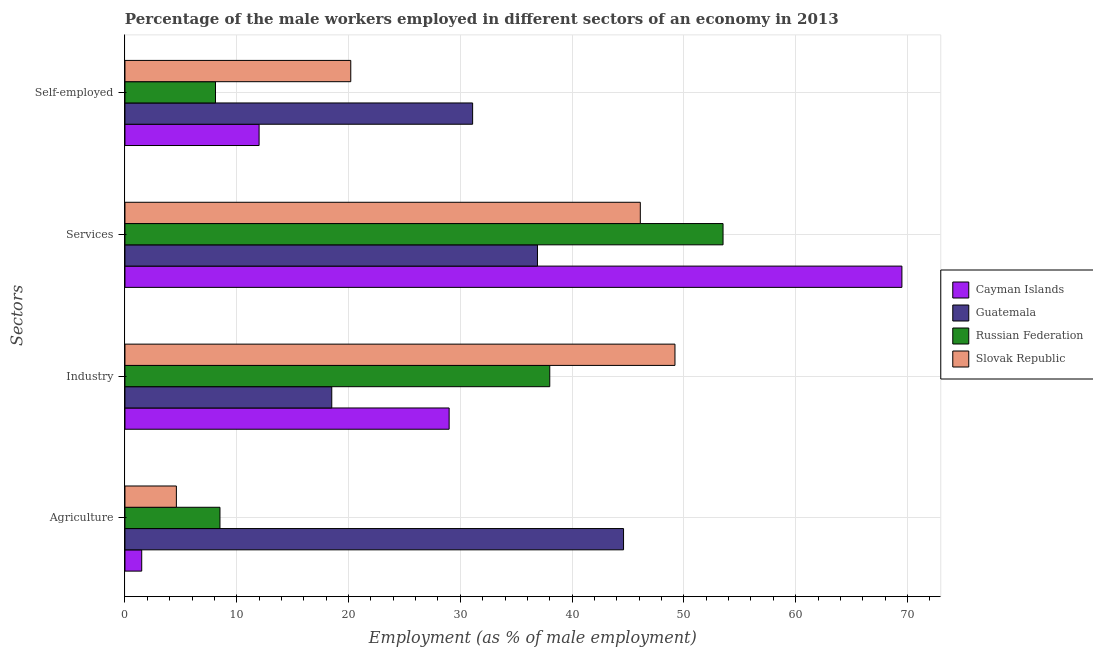Are the number of bars on each tick of the Y-axis equal?
Provide a succinct answer. Yes. What is the label of the 4th group of bars from the top?
Give a very brief answer. Agriculture. What is the percentage of self employed male workers in Russian Federation?
Offer a terse response. 8.1. Across all countries, what is the maximum percentage of male workers in industry?
Your response must be concise. 49.2. Across all countries, what is the minimum percentage of male workers in services?
Keep it short and to the point. 36.9. In which country was the percentage of self employed male workers maximum?
Provide a succinct answer. Guatemala. In which country was the percentage of male workers in industry minimum?
Make the answer very short. Guatemala. What is the total percentage of male workers in industry in the graph?
Your answer should be compact. 134.7. What is the difference between the percentage of male workers in agriculture in Guatemala and that in Slovak Republic?
Give a very brief answer. 40. What is the difference between the percentage of self employed male workers in Russian Federation and the percentage of male workers in services in Cayman Islands?
Ensure brevity in your answer.  -61.4. What is the average percentage of self employed male workers per country?
Make the answer very short. 17.85. What is the difference between the percentage of male workers in services and percentage of male workers in industry in Cayman Islands?
Provide a succinct answer. 40.5. What is the ratio of the percentage of male workers in services in Slovak Republic to that in Guatemala?
Keep it short and to the point. 1.25. Is the difference between the percentage of self employed male workers in Guatemala and Russian Federation greater than the difference between the percentage of male workers in industry in Guatemala and Russian Federation?
Provide a succinct answer. Yes. What is the difference between the highest and the second highest percentage of male workers in industry?
Your response must be concise. 11.2. What is the difference between the highest and the lowest percentage of male workers in agriculture?
Your response must be concise. 43.1. In how many countries, is the percentage of self employed male workers greater than the average percentage of self employed male workers taken over all countries?
Keep it short and to the point. 2. Is it the case that in every country, the sum of the percentage of self employed male workers and percentage of male workers in services is greater than the sum of percentage of male workers in industry and percentage of male workers in agriculture?
Keep it short and to the point. Yes. What does the 4th bar from the top in Services represents?
Provide a short and direct response. Cayman Islands. What does the 4th bar from the bottom in Services represents?
Provide a succinct answer. Slovak Republic. Are all the bars in the graph horizontal?
Ensure brevity in your answer.  Yes. How many countries are there in the graph?
Your response must be concise. 4. Are the values on the major ticks of X-axis written in scientific E-notation?
Your answer should be compact. No. Does the graph contain any zero values?
Offer a very short reply. No. Does the graph contain grids?
Give a very brief answer. Yes. How many legend labels are there?
Your answer should be compact. 4. How are the legend labels stacked?
Provide a short and direct response. Vertical. What is the title of the graph?
Give a very brief answer. Percentage of the male workers employed in different sectors of an economy in 2013. What is the label or title of the X-axis?
Your response must be concise. Employment (as % of male employment). What is the label or title of the Y-axis?
Provide a succinct answer. Sectors. What is the Employment (as % of male employment) in Cayman Islands in Agriculture?
Offer a terse response. 1.5. What is the Employment (as % of male employment) of Guatemala in Agriculture?
Ensure brevity in your answer.  44.6. What is the Employment (as % of male employment) of Russian Federation in Agriculture?
Provide a short and direct response. 8.5. What is the Employment (as % of male employment) in Slovak Republic in Agriculture?
Your response must be concise. 4.6. What is the Employment (as % of male employment) of Cayman Islands in Industry?
Offer a very short reply. 29. What is the Employment (as % of male employment) of Russian Federation in Industry?
Provide a short and direct response. 38. What is the Employment (as % of male employment) in Slovak Republic in Industry?
Make the answer very short. 49.2. What is the Employment (as % of male employment) in Cayman Islands in Services?
Make the answer very short. 69.5. What is the Employment (as % of male employment) in Guatemala in Services?
Provide a succinct answer. 36.9. What is the Employment (as % of male employment) of Russian Federation in Services?
Offer a very short reply. 53.5. What is the Employment (as % of male employment) of Slovak Republic in Services?
Offer a terse response. 46.1. What is the Employment (as % of male employment) in Guatemala in Self-employed?
Offer a very short reply. 31.1. What is the Employment (as % of male employment) in Russian Federation in Self-employed?
Offer a very short reply. 8.1. What is the Employment (as % of male employment) of Slovak Republic in Self-employed?
Provide a succinct answer. 20.2. Across all Sectors, what is the maximum Employment (as % of male employment) in Cayman Islands?
Offer a very short reply. 69.5. Across all Sectors, what is the maximum Employment (as % of male employment) in Guatemala?
Make the answer very short. 44.6. Across all Sectors, what is the maximum Employment (as % of male employment) in Russian Federation?
Your answer should be compact. 53.5. Across all Sectors, what is the maximum Employment (as % of male employment) in Slovak Republic?
Make the answer very short. 49.2. Across all Sectors, what is the minimum Employment (as % of male employment) of Russian Federation?
Provide a short and direct response. 8.1. Across all Sectors, what is the minimum Employment (as % of male employment) in Slovak Republic?
Keep it short and to the point. 4.6. What is the total Employment (as % of male employment) in Cayman Islands in the graph?
Your response must be concise. 112. What is the total Employment (as % of male employment) in Guatemala in the graph?
Your answer should be very brief. 131.1. What is the total Employment (as % of male employment) in Russian Federation in the graph?
Offer a very short reply. 108.1. What is the total Employment (as % of male employment) of Slovak Republic in the graph?
Give a very brief answer. 120.1. What is the difference between the Employment (as % of male employment) of Cayman Islands in Agriculture and that in Industry?
Offer a terse response. -27.5. What is the difference between the Employment (as % of male employment) of Guatemala in Agriculture and that in Industry?
Give a very brief answer. 26.1. What is the difference between the Employment (as % of male employment) in Russian Federation in Agriculture and that in Industry?
Your answer should be very brief. -29.5. What is the difference between the Employment (as % of male employment) of Slovak Republic in Agriculture and that in Industry?
Keep it short and to the point. -44.6. What is the difference between the Employment (as % of male employment) of Cayman Islands in Agriculture and that in Services?
Ensure brevity in your answer.  -68. What is the difference between the Employment (as % of male employment) in Russian Federation in Agriculture and that in Services?
Ensure brevity in your answer.  -45. What is the difference between the Employment (as % of male employment) in Slovak Republic in Agriculture and that in Services?
Your answer should be very brief. -41.5. What is the difference between the Employment (as % of male employment) of Cayman Islands in Agriculture and that in Self-employed?
Keep it short and to the point. -10.5. What is the difference between the Employment (as % of male employment) in Guatemala in Agriculture and that in Self-employed?
Provide a succinct answer. 13.5. What is the difference between the Employment (as % of male employment) of Slovak Republic in Agriculture and that in Self-employed?
Make the answer very short. -15.6. What is the difference between the Employment (as % of male employment) in Cayman Islands in Industry and that in Services?
Give a very brief answer. -40.5. What is the difference between the Employment (as % of male employment) in Guatemala in Industry and that in Services?
Offer a terse response. -18.4. What is the difference between the Employment (as % of male employment) in Russian Federation in Industry and that in Services?
Ensure brevity in your answer.  -15.5. What is the difference between the Employment (as % of male employment) of Guatemala in Industry and that in Self-employed?
Provide a short and direct response. -12.6. What is the difference between the Employment (as % of male employment) in Russian Federation in Industry and that in Self-employed?
Your answer should be very brief. 29.9. What is the difference between the Employment (as % of male employment) of Slovak Republic in Industry and that in Self-employed?
Keep it short and to the point. 29. What is the difference between the Employment (as % of male employment) in Cayman Islands in Services and that in Self-employed?
Give a very brief answer. 57.5. What is the difference between the Employment (as % of male employment) of Guatemala in Services and that in Self-employed?
Your answer should be compact. 5.8. What is the difference between the Employment (as % of male employment) in Russian Federation in Services and that in Self-employed?
Offer a very short reply. 45.4. What is the difference between the Employment (as % of male employment) of Slovak Republic in Services and that in Self-employed?
Your response must be concise. 25.9. What is the difference between the Employment (as % of male employment) in Cayman Islands in Agriculture and the Employment (as % of male employment) in Russian Federation in Industry?
Provide a short and direct response. -36.5. What is the difference between the Employment (as % of male employment) in Cayman Islands in Agriculture and the Employment (as % of male employment) in Slovak Republic in Industry?
Offer a very short reply. -47.7. What is the difference between the Employment (as % of male employment) of Guatemala in Agriculture and the Employment (as % of male employment) of Russian Federation in Industry?
Offer a terse response. 6.6. What is the difference between the Employment (as % of male employment) of Russian Federation in Agriculture and the Employment (as % of male employment) of Slovak Republic in Industry?
Give a very brief answer. -40.7. What is the difference between the Employment (as % of male employment) in Cayman Islands in Agriculture and the Employment (as % of male employment) in Guatemala in Services?
Offer a terse response. -35.4. What is the difference between the Employment (as % of male employment) in Cayman Islands in Agriculture and the Employment (as % of male employment) in Russian Federation in Services?
Offer a very short reply. -52. What is the difference between the Employment (as % of male employment) in Cayman Islands in Agriculture and the Employment (as % of male employment) in Slovak Republic in Services?
Ensure brevity in your answer.  -44.6. What is the difference between the Employment (as % of male employment) in Guatemala in Agriculture and the Employment (as % of male employment) in Russian Federation in Services?
Your answer should be compact. -8.9. What is the difference between the Employment (as % of male employment) of Russian Federation in Agriculture and the Employment (as % of male employment) of Slovak Republic in Services?
Keep it short and to the point. -37.6. What is the difference between the Employment (as % of male employment) in Cayman Islands in Agriculture and the Employment (as % of male employment) in Guatemala in Self-employed?
Offer a terse response. -29.6. What is the difference between the Employment (as % of male employment) of Cayman Islands in Agriculture and the Employment (as % of male employment) of Russian Federation in Self-employed?
Your response must be concise. -6.6. What is the difference between the Employment (as % of male employment) of Cayman Islands in Agriculture and the Employment (as % of male employment) of Slovak Republic in Self-employed?
Provide a short and direct response. -18.7. What is the difference between the Employment (as % of male employment) in Guatemala in Agriculture and the Employment (as % of male employment) in Russian Federation in Self-employed?
Your response must be concise. 36.5. What is the difference between the Employment (as % of male employment) of Guatemala in Agriculture and the Employment (as % of male employment) of Slovak Republic in Self-employed?
Make the answer very short. 24.4. What is the difference between the Employment (as % of male employment) of Russian Federation in Agriculture and the Employment (as % of male employment) of Slovak Republic in Self-employed?
Your response must be concise. -11.7. What is the difference between the Employment (as % of male employment) of Cayman Islands in Industry and the Employment (as % of male employment) of Guatemala in Services?
Your answer should be compact. -7.9. What is the difference between the Employment (as % of male employment) of Cayman Islands in Industry and the Employment (as % of male employment) of Russian Federation in Services?
Your response must be concise. -24.5. What is the difference between the Employment (as % of male employment) of Cayman Islands in Industry and the Employment (as % of male employment) of Slovak Republic in Services?
Your answer should be very brief. -17.1. What is the difference between the Employment (as % of male employment) in Guatemala in Industry and the Employment (as % of male employment) in Russian Federation in Services?
Keep it short and to the point. -35. What is the difference between the Employment (as % of male employment) in Guatemala in Industry and the Employment (as % of male employment) in Slovak Republic in Services?
Ensure brevity in your answer.  -27.6. What is the difference between the Employment (as % of male employment) of Russian Federation in Industry and the Employment (as % of male employment) of Slovak Republic in Services?
Offer a terse response. -8.1. What is the difference between the Employment (as % of male employment) in Cayman Islands in Industry and the Employment (as % of male employment) in Russian Federation in Self-employed?
Offer a terse response. 20.9. What is the difference between the Employment (as % of male employment) in Guatemala in Industry and the Employment (as % of male employment) in Russian Federation in Self-employed?
Ensure brevity in your answer.  10.4. What is the difference between the Employment (as % of male employment) in Guatemala in Industry and the Employment (as % of male employment) in Slovak Republic in Self-employed?
Offer a terse response. -1.7. What is the difference between the Employment (as % of male employment) in Russian Federation in Industry and the Employment (as % of male employment) in Slovak Republic in Self-employed?
Your answer should be very brief. 17.8. What is the difference between the Employment (as % of male employment) of Cayman Islands in Services and the Employment (as % of male employment) of Guatemala in Self-employed?
Offer a very short reply. 38.4. What is the difference between the Employment (as % of male employment) of Cayman Islands in Services and the Employment (as % of male employment) of Russian Federation in Self-employed?
Your answer should be very brief. 61.4. What is the difference between the Employment (as % of male employment) of Cayman Islands in Services and the Employment (as % of male employment) of Slovak Republic in Self-employed?
Provide a short and direct response. 49.3. What is the difference between the Employment (as % of male employment) in Guatemala in Services and the Employment (as % of male employment) in Russian Federation in Self-employed?
Ensure brevity in your answer.  28.8. What is the difference between the Employment (as % of male employment) of Guatemala in Services and the Employment (as % of male employment) of Slovak Republic in Self-employed?
Keep it short and to the point. 16.7. What is the difference between the Employment (as % of male employment) of Russian Federation in Services and the Employment (as % of male employment) of Slovak Republic in Self-employed?
Give a very brief answer. 33.3. What is the average Employment (as % of male employment) of Guatemala per Sectors?
Make the answer very short. 32.77. What is the average Employment (as % of male employment) in Russian Federation per Sectors?
Your answer should be very brief. 27.02. What is the average Employment (as % of male employment) in Slovak Republic per Sectors?
Provide a succinct answer. 30.02. What is the difference between the Employment (as % of male employment) in Cayman Islands and Employment (as % of male employment) in Guatemala in Agriculture?
Your response must be concise. -43.1. What is the difference between the Employment (as % of male employment) of Cayman Islands and Employment (as % of male employment) of Slovak Republic in Agriculture?
Offer a very short reply. -3.1. What is the difference between the Employment (as % of male employment) of Guatemala and Employment (as % of male employment) of Russian Federation in Agriculture?
Make the answer very short. 36.1. What is the difference between the Employment (as % of male employment) of Russian Federation and Employment (as % of male employment) of Slovak Republic in Agriculture?
Keep it short and to the point. 3.9. What is the difference between the Employment (as % of male employment) in Cayman Islands and Employment (as % of male employment) in Slovak Republic in Industry?
Offer a terse response. -20.2. What is the difference between the Employment (as % of male employment) in Guatemala and Employment (as % of male employment) in Russian Federation in Industry?
Make the answer very short. -19.5. What is the difference between the Employment (as % of male employment) in Guatemala and Employment (as % of male employment) in Slovak Republic in Industry?
Provide a short and direct response. -30.7. What is the difference between the Employment (as % of male employment) of Cayman Islands and Employment (as % of male employment) of Guatemala in Services?
Your response must be concise. 32.6. What is the difference between the Employment (as % of male employment) of Cayman Islands and Employment (as % of male employment) of Slovak Republic in Services?
Offer a very short reply. 23.4. What is the difference between the Employment (as % of male employment) in Guatemala and Employment (as % of male employment) in Russian Federation in Services?
Provide a short and direct response. -16.6. What is the difference between the Employment (as % of male employment) in Cayman Islands and Employment (as % of male employment) in Guatemala in Self-employed?
Offer a terse response. -19.1. What is the difference between the Employment (as % of male employment) in Guatemala and Employment (as % of male employment) in Russian Federation in Self-employed?
Your response must be concise. 23. What is the difference between the Employment (as % of male employment) in Guatemala and Employment (as % of male employment) in Slovak Republic in Self-employed?
Provide a short and direct response. 10.9. What is the difference between the Employment (as % of male employment) of Russian Federation and Employment (as % of male employment) of Slovak Republic in Self-employed?
Offer a very short reply. -12.1. What is the ratio of the Employment (as % of male employment) in Cayman Islands in Agriculture to that in Industry?
Offer a very short reply. 0.05. What is the ratio of the Employment (as % of male employment) of Guatemala in Agriculture to that in Industry?
Offer a terse response. 2.41. What is the ratio of the Employment (as % of male employment) in Russian Federation in Agriculture to that in Industry?
Offer a very short reply. 0.22. What is the ratio of the Employment (as % of male employment) in Slovak Republic in Agriculture to that in Industry?
Make the answer very short. 0.09. What is the ratio of the Employment (as % of male employment) of Cayman Islands in Agriculture to that in Services?
Offer a very short reply. 0.02. What is the ratio of the Employment (as % of male employment) in Guatemala in Agriculture to that in Services?
Keep it short and to the point. 1.21. What is the ratio of the Employment (as % of male employment) in Russian Federation in Agriculture to that in Services?
Offer a very short reply. 0.16. What is the ratio of the Employment (as % of male employment) in Slovak Republic in Agriculture to that in Services?
Offer a terse response. 0.1. What is the ratio of the Employment (as % of male employment) of Guatemala in Agriculture to that in Self-employed?
Your answer should be compact. 1.43. What is the ratio of the Employment (as % of male employment) in Russian Federation in Agriculture to that in Self-employed?
Your response must be concise. 1.05. What is the ratio of the Employment (as % of male employment) in Slovak Republic in Agriculture to that in Self-employed?
Your answer should be very brief. 0.23. What is the ratio of the Employment (as % of male employment) in Cayman Islands in Industry to that in Services?
Your response must be concise. 0.42. What is the ratio of the Employment (as % of male employment) of Guatemala in Industry to that in Services?
Offer a very short reply. 0.5. What is the ratio of the Employment (as % of male employment) in Russian Federation in Industry to that in Services?
Your answer should be compact. 0.71. What is the ratio of the Employment (as % of male employment) in Slovak Republic in Industry to that in Services?
Offer a very short reply. 1.07. What is the ratio of the Employment (as % of male employment) in Cayman Islands in Industry to that in Self-employed?
Your response must be concise. 2.42. What is the ratio of the Employment (as % of male employment) of Guatemala in Industry to that in Self-employed?
Give a very brief answer. 0.59. What is the ratio of the Employment (as % of male employment) in Russian Federation in Industry to that in Self-employed?
Your response must be concise. 4.69. What is the ratio of the Employment (as % of male employment) in Slovak Republic in Industry to that in Self-employed?
Your answer should be compact. 2.44. What is the ratio of the Employment (as % of male employment) in Cayman Islands in Services to that in Self-employed?
Your answer should be very brief. 5.79. What is the ratio of the Employment (as % of male employment) in Guatemala in Services to that in Self-employed?
Your response must be concise. 1.19. What is the ratio of the Employment (as % of male employment) in Russian Federation in Services to that in Self-employed?
Offer a very short reply. 6.6. What is the ratio of the Employment (as % of male employment) of Slovak Republic in Services to that in Self-employed?
Your response must be concise. 2.28. What is the difference between the highest and the second highest Employment (as % of male employment) in Cayman Islands?
Provide a succinct answer. 40.5. What is the difference between the highest and the second highest Employment (as % of male employment) in Russian Federation?
Give a very brief answer. 15.5. What is the difference between the highest and the second highest Employment (as % of male employment) of Slovak Republic?
Provide a short and direct response. 3.1. What is the difference between the highest and the lowest Employment (as % of male employment) in Cayman Islands?
Provide a short and direct response. 68. What is the difference between the highest and the lowest Employment (as % of male employment) in Guatemala?
Make the answer very short. 26.1. What is the difference between the highest and the lowest Employment (as % of male employment) in Russian Federation?
Ensure brevity in your answer.  45.4. What is the difference between the highest and the lowest Employment (as % of male employment) in Slovak Republic?
Make the answer very short. 44.6. 